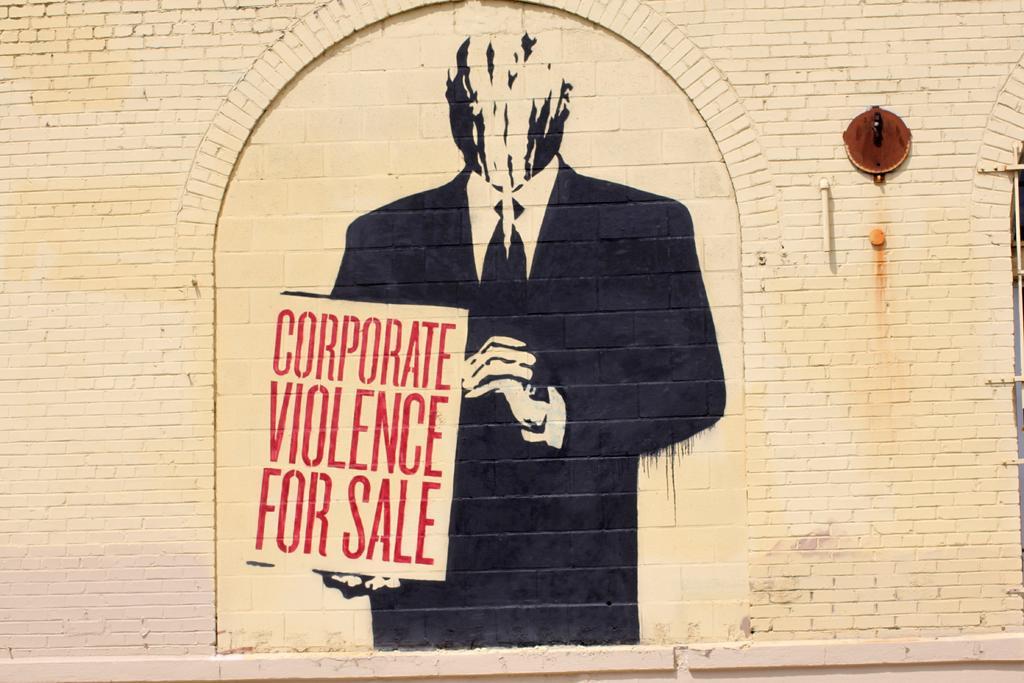Could you give a brief overview of what you see in this image? In this picture we can see a wall, on this wall we can see a painting of a person holding a board. 